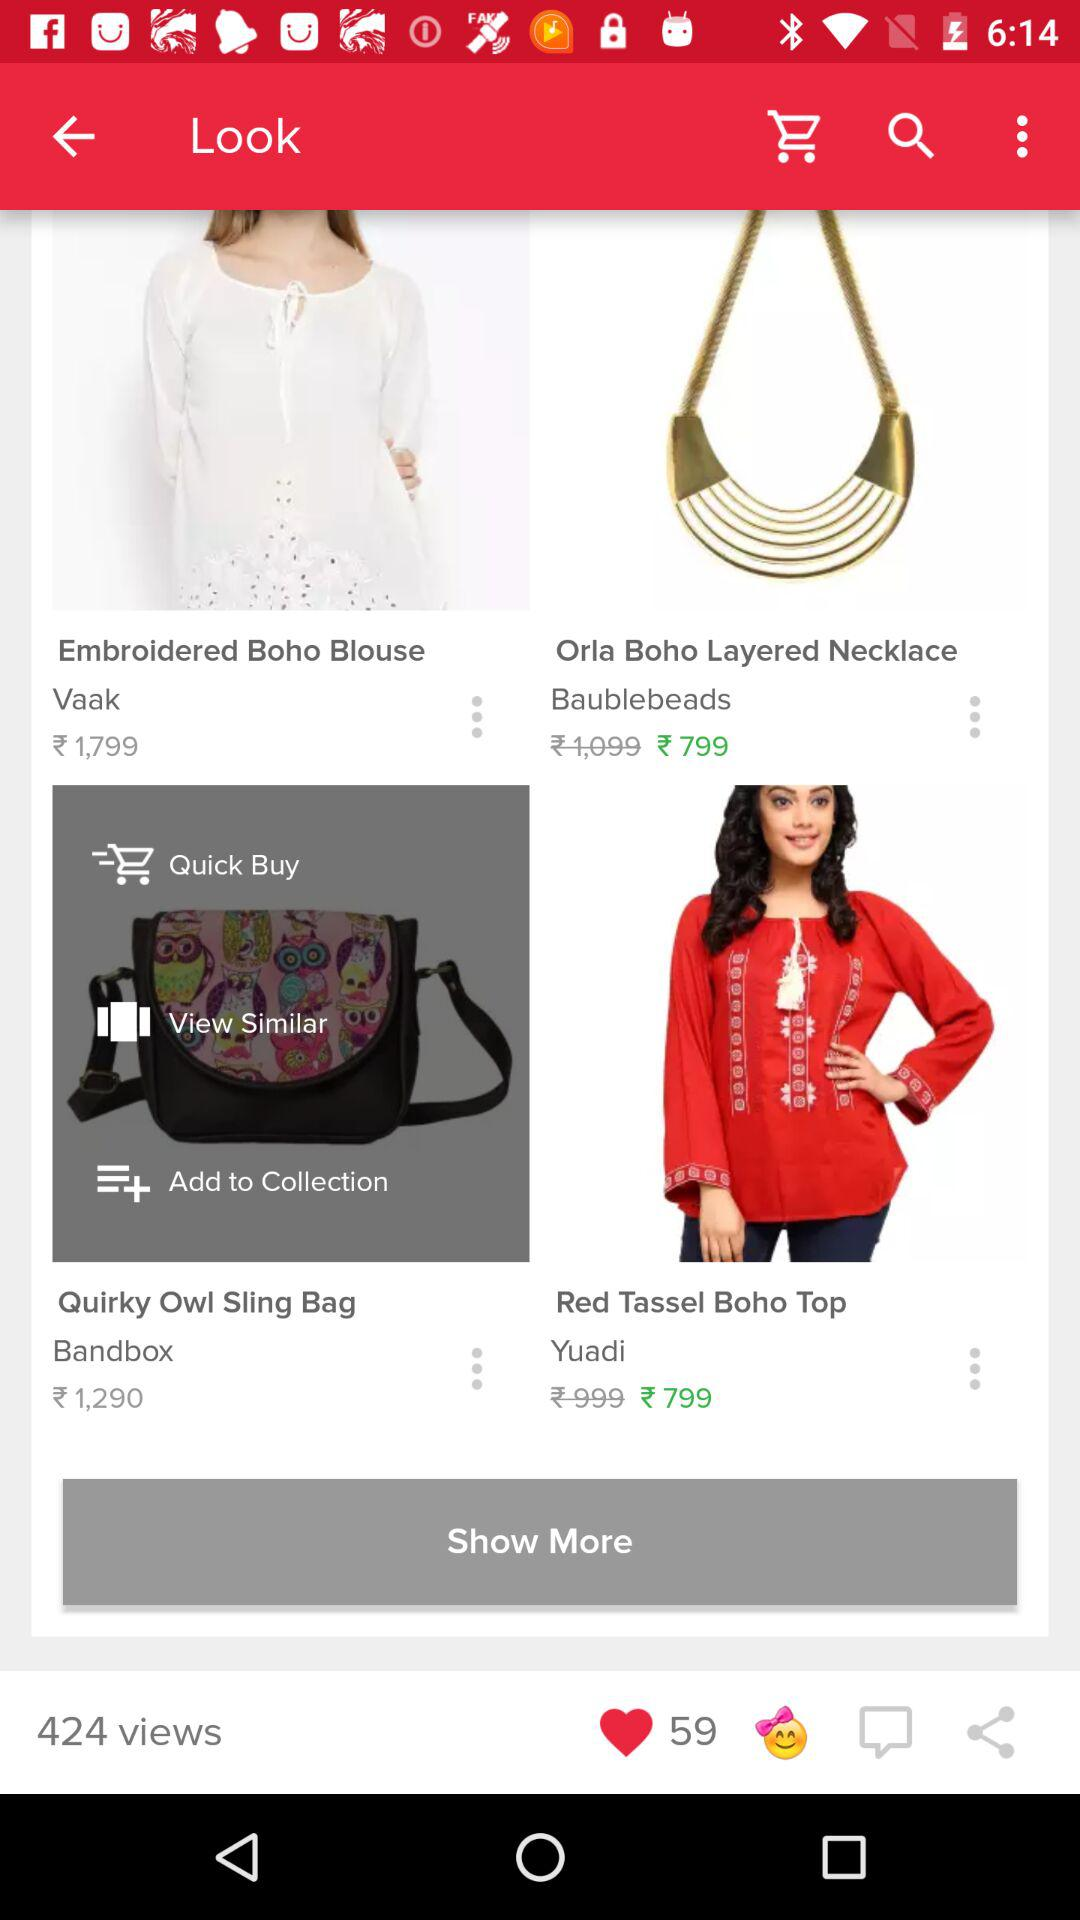What is the name of the item under the "Quick Buy" category? The name of the item under the "Quick Buy" category is "Quirky Owl Sling Bag". 